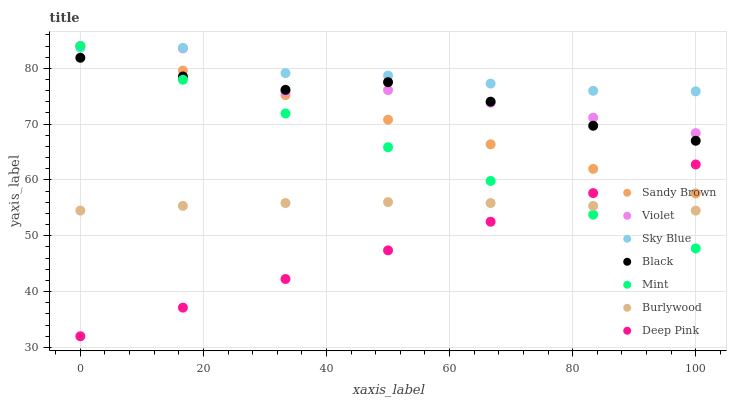Does Deep Pink have the minimum area under the curve?
Answer yes or no. Yes. Does Sky Blue have the maximum area under the curve?
Answer yes or no. Yes. Does Burlywood have the minimum area under the curve?
Answer yes or no. No. Does Burlywood have the maximum area under the curve?
Answer yes or no. No. Is Mint the smoothest?
Answer yes or no. Yes. Is Violet the roughest?
Answer yes or no. Yes. Is Burlywood the smoothest?
Answer yes or no. No. Is Burlywood the roughest?
Answer yes or no. No. Does Deep Pink have the lowest value?
Answer yes or no. Yes. Does Burlywood have the lowest value?
Answer yes or no. No. Does Sandy Brown have the highest value?
Answer yes or no. Yes. Does Burlywood have the highest value?
Answer yes or no. No. Is Deep Pink less than Black?
Answer yes or no. Yes. Is Violet greater than Deep Pink?
Answer yes or no. Yes. Does Deep Pink intersect Burlywood?
Answer yes or no. Yes. Is Deep Pink less than Burlywood?
Answer yes or no. No. Is Deep Pink greater than Burlywood?
Answer yes or no. No. Does Deep Pink intersect Black?
Answer yes or no. No. 